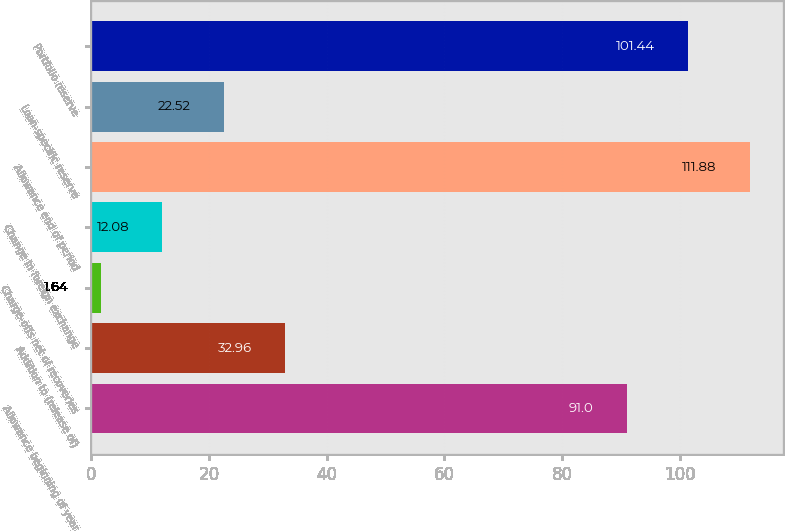Convert chart to OTSL. <chart><loc_0><loc_0><loc_500><loc_500><bar_chart><fcel>Allowance beginning of year<fcel>Addition to (release of)<fcel>Charge-offs net of recoveries<fcel>Change in foreign exchange<fcel>Allowance end of period<fcel>Loan-specific reserve<fcel>Portfolio reserve<nl><fcel>91<fcel>32.96<fcel>1.64<fcel>12.08<fcel>111.88<fcel>22.52<fcel>101.44<nl></chart> 